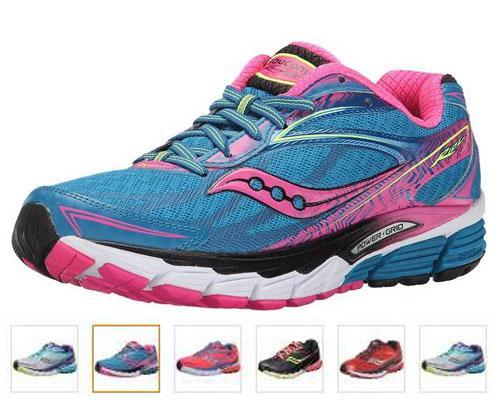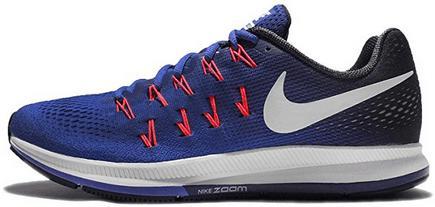The first image is the image on the left, the second image is the image on the right. Evaluate the accuracy of this statement regarding the images: "Each image shows one shoe with blue in its color scheme, and all shoes face rightward.". Is it true? Answer yes or no. No. The first image is the image on the left, the second image is the image on the right. For the images shown, is this caption "Both shoes have the same logo across the side." true? Answer yes or no. No. 